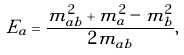<formula> <loc_0><loc_0><loc_500><loc_500>E _ { a } = \frac { m _ { a b } ^ { 2 } + m _ { a } ^ { 2 } - m _ { b } ^ { 2 } } { 2 m _ { a b } } ,</formula> 